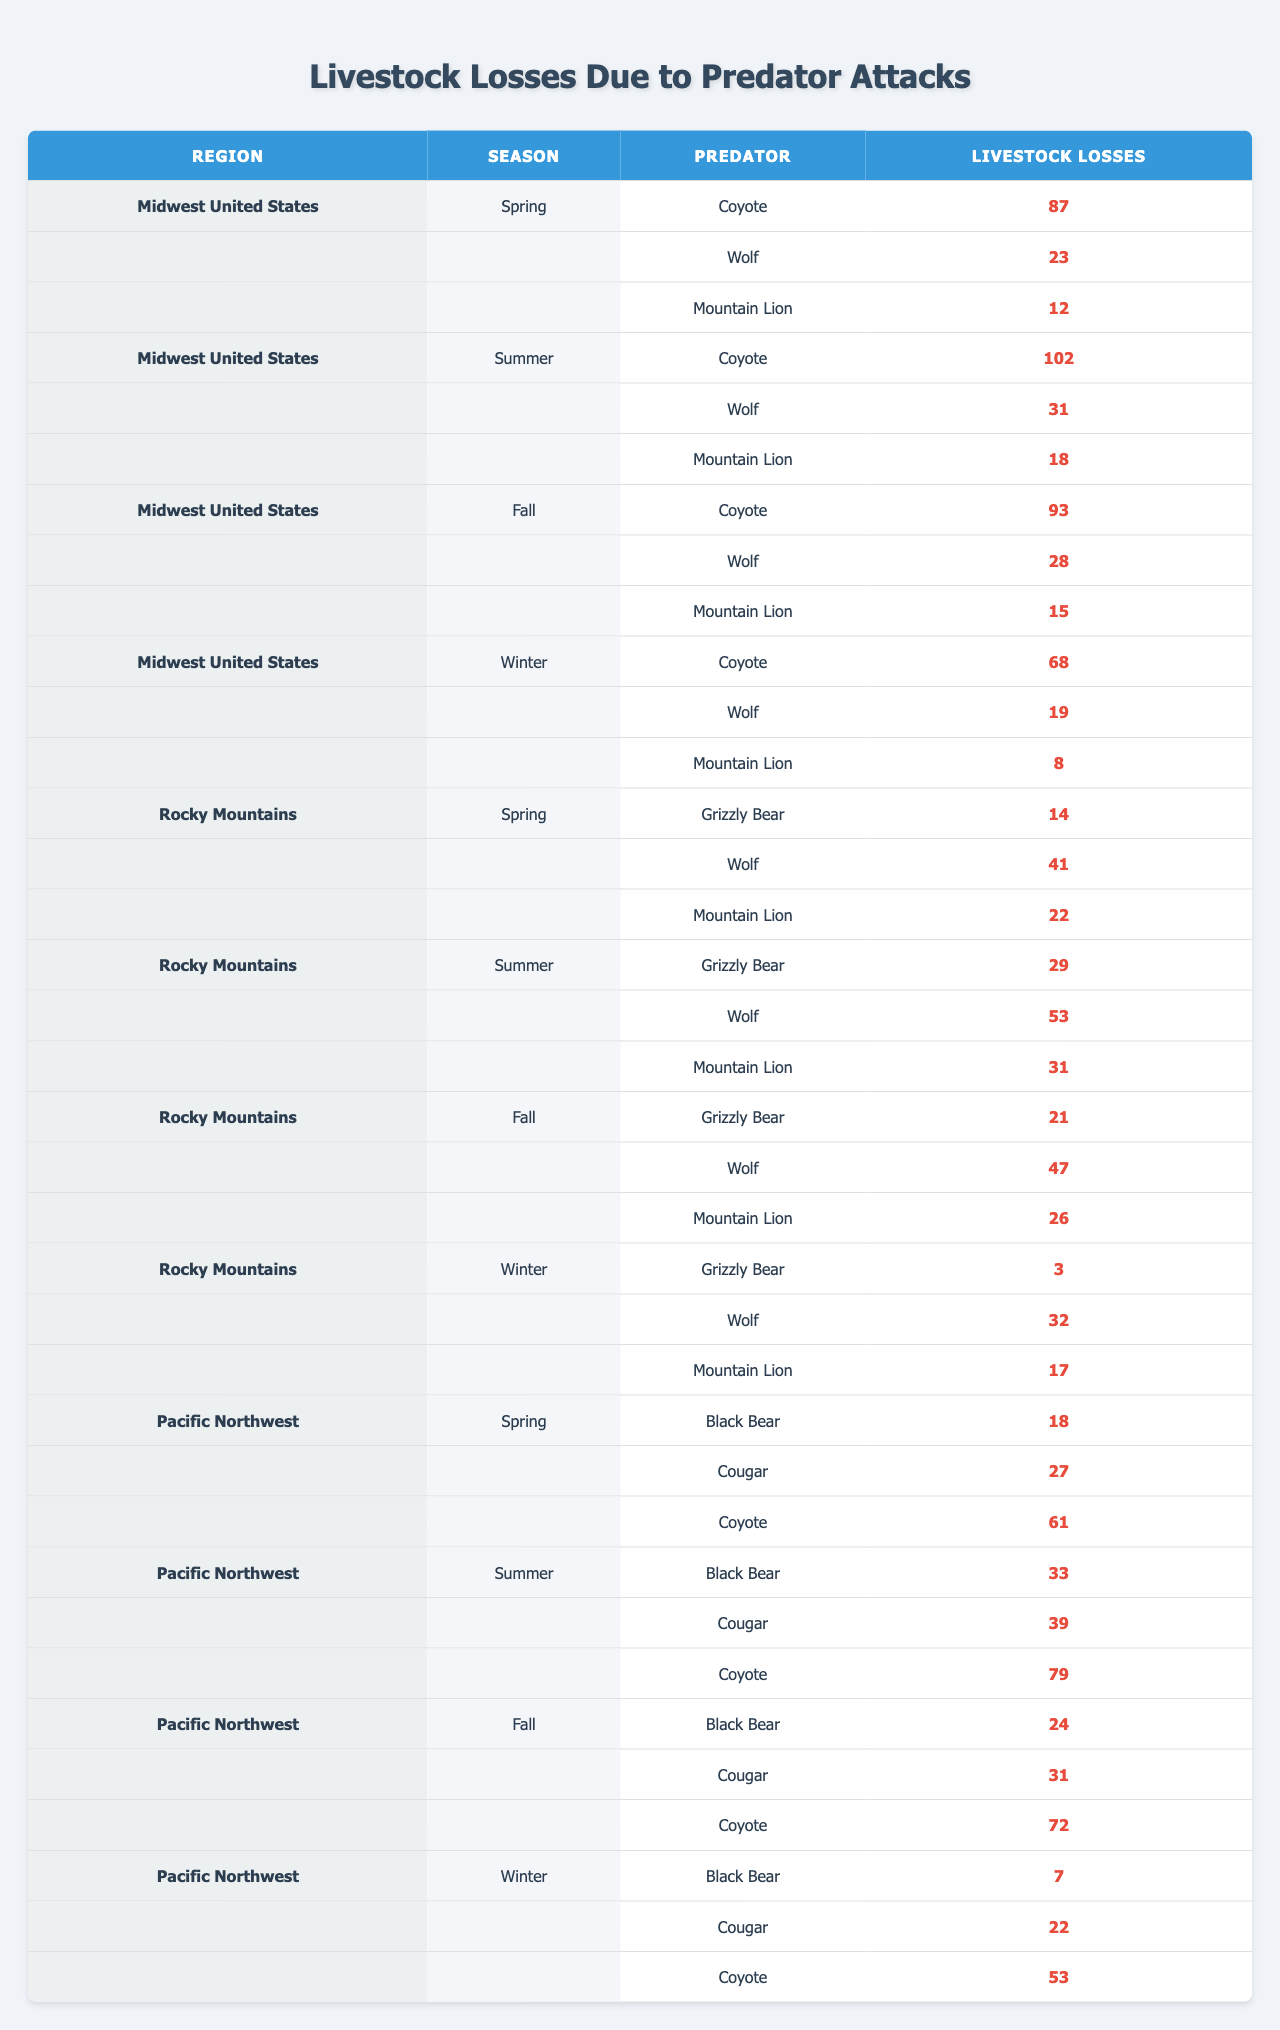What region has the highest livestock losses due to predators in summer? In the Summer season, the Midwest United States has losses of 102 due to Coyote, while the Rocky Mountains have 29 from Grizzly Bear and 53 from Wolf, and the Pacific Northwest has 79 from Coyote. Therefore, the highest losses are in the Midwest United States.
Answer: Midwest United States Which predator caused the most livestock losses in the Rocky Mountains during the spring? In Spring, the losses are 14 from Grizzly Bear, 41 from Wolf, and 22 from Mountain Lion in the Rocky Mountains. The Wolf caused the most losses with 41.
Answer: Wolf What is the total livestock loss in the Pacific Northwest during the fall? In Fall, the Pacific Northwest has losses of 24 from Black Bear, 31 from Cougar, and 72 from Coyote. Adding these gives 24 + 31 + 72 = 127.
Answer: 127 Which predator caused the least livestock losses in the Midwest during winter? In Winter, the losses in the Midwest are 68 from Coyote, 19 from Wolf, and 8 from Mountain Lion. The Mountain Lion caused the least losses with 8.
Answer: Mountain Lion How many livestock losses occurred from Wolves across all seasons in the Rocky Mountains? The losses from Wolves are 41 in Spring, 53 in Summer, 47 in Fall, and 32 in Winter. Summing these losses gives 41 + 53 + 47 + 32 = 173.
Answer: 173 Which season recorded the highest livestock losses from Coyotes in the Midwest? In the Midwest, the livestock losses from Coyotes are 87 in Spring, 102 in Summer, 93 in Fall, and 68 in Winter. The highest loss recorded is 102 in Summer.
Answer: Summer Is it true that the Grizzly Bear caused more livestock losses than the Mountain Lion in the Rocky Mountains during Fall? In Fall, Grizzly Bear caused 21 losses while Mountain Lion caused 26 losses. Therefore, it is false that Grizzly Bear caused more losses than Mountain Lion.
Answer: No What is the average livestock loss caused by Cougars in the Pacific Northwest across all seasons? The losses caused by Cougars in the Pacific Northwest are 27 in Spring, 39 in Summer, 31 in Fall, and 22 in Winter. The total losses are 27 + 39 + 31 + 22 = 119. The average is 119 / 4 = 29.75.
Answer: 29.75 Which region and season combination shows the most significant livestock loss due to a specific predator species? Upon analyzing the table, Midwest United States in Summer shows the most significant livestock loss due to Coyote with 102 losses. This is higher than any other predator and combination in the table.
Answer: Midwest United States, Summer What is the total livestock loss from all predators in the Midwest for the entire year? In the Midwest losses for each season are as follows: Spring 122 (87 + 23 + 12), Summer 151 (102 + 31 + 18), Fall 136 (93 + 28 + 15), and Winter 95 (68 + 19 + 8). Totaling these gives 122 + 151 + 136 + 95 = 504.
Answer: 504 